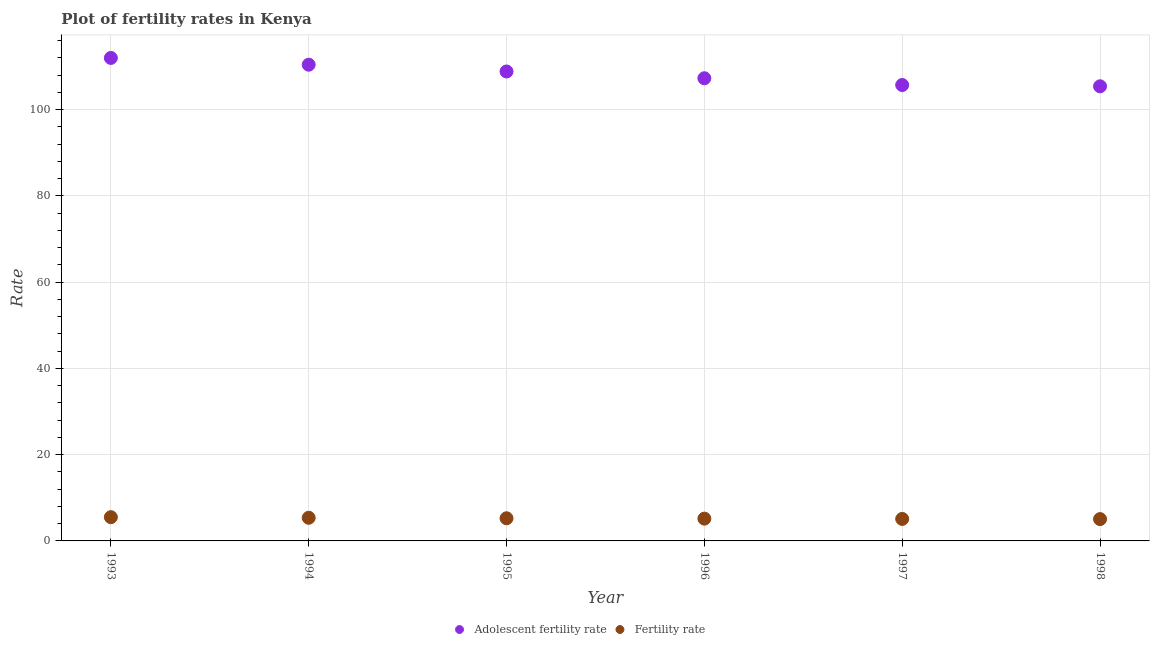Is the number of dotlines equal to the number of legend labels?
Give a very brief answer. Yes. What is the adolescent fertility rate in 1998?
Your response must be concise. 105.4. Across all years, what is the maximum fertility rate?
Offer a terse response. 5.51. Across all years, what is the minimum adolescent fertility rate?
Offer a very short reply. 105.4. In which year was the fertility rate minimum?
Provide a succinct answer. 1998. What is the total fertility rate in the graph?
Make the answer very short. 31.45. What is the difference between the fertility rate in 1997 and that in 1998?
Provide a short and direct response. 0.04. What is the difference between the adolescent fertility rate in 1997 and the fertility rate in 1998?
Your answer should be very brief. 100.64. What is the average fertility rate per year?
Give a very brief answer. 5.24. In the year 1997, what is the difference between the fertility rate and adolescent fertility rate?
Keep it short and to the point. -100.6. What is the ratio of the fertility rate in 1996 to that in 1998?
Offer a very short reply. 1.02. Is the adolescent fertility rate in 1997 less than that in 1998?
Provide a short and direct response. No. What is the difference between the highest and the second highest adolescent fertility rate?
Your answer should be compact. 1.57. What is the difference between the highest and the lowest adolescent fertility rate?
Provide a succinct answer. 6.58. In how many years, is the fertility rate greater than the average fertility rate taken over all years?
Provide a short and direct response. 3. Is the adolescent fertility rate strictly less than the fertility rate over the years?
Your response must be concise. No. What is the difference between two consecutive major ticks on the Y-axis?
Give a very brief answer. 20. Are the values on the major ticks of Y-axis written in scientific E-notation?
Offer a terse response. No. Does the graph contain any zero values?
Offer a very short reply. No. Where does the legend appear in the graph?
Offer a terse response. Bottom center. How many legend labels are there?
Keep it short and to the point. 2. How are the legend labels stacked?
Your answer should be very brief. Horizontal. What is the title of the graph?
Provide a short and direct response. Plot of fertility rates in Kenya. Does "Gasoline" appear as one of the legend labels in the graph?
Your answer should be very brief. No. What is the label or title of the X-axis?
Provide a short and direct response. Year. What is the label or title of the Y-axis?
Provide a succinct answer. Rate. What is the Rate in Adolescent fertility rate in 1993?
Your answer should be very brief. 111.98. What is the Rate in Fertility rate in 1993?
Give a very brief answer. 5.51. What is the Rate of Adolescent fertility rate in 1994?
Give a very brief answer. 110.41. What is the Rate in Fertility rate in 1994?
Make the answer very short. 5.37. What is the Rate in Adolescent fertility rate in 1995?
Provide a succinct answer. 108.84. What is the Rate in Fertility rate in 1995?
Offer a very short reply. 5.25. What is the Rate of Adolescent fertility rate in 1996?
Provide a short and direct response. 107.27. What is the Rate of Fertility rate in 1996?
Your answer should be compact. 5.17. What is the Rate of Adolescent fertility rate in 1997?
Offer a terse response. 105.7. What is the Rate in Fertility rate in 1997?
Your answer should be compact. 5.1. What is the Rate of Adolescent fertility rate in 1998?
Your answer should be compact. 105.4. What is the Rate in Fertility rate in 1998?
Provide a succinct answer. 5.06. Across all years, what is the maximum Rate in Adolescent fertility rate?
Keep it short and to the point. 111.98. Across all years, what is the maximum Rate of Fertility rate?
Keep it short and to the point. 5.51. Across all years, what is the minimum Rate in Adolescent fertility rate?
Offer a very short reply. 105.4. Across all years, what is the minimum Rate of Fertility rate?
Keep it short and to the point. 5.06. What is the total Rate of Adolescent fertility rate in the graph?
Provide a succinct answer. 649.59. What is the total Rate of Fertility rate in the graph?
Offer a terse response. 31.45. What is the difference between the Rate of Adolescent fertility rate in 1993 and that in 1994?
Provide a succinct answer. 1.57. What is the difference between the Rate of Fertility rate in 1993 and that in 1994?
Your answer should be compact. 0.14. What is the difference between the Rate of Adolescent fertility rate in 1993 and that in 1995?
Offer a terse response. 3.14. What is the difference between the Rate in Fertility rate in 1993 and that in 1995?
Give a very brief answer. 0.26. What is the difference between the Rate in Adolescent fertility rate in 1993 and that in 1996?
Your answer should be very brief. 4.71. What is the difference between the Rate in Fertility rate in 1993 and that in 1996?
Provide a short and direct response. 0.34. What is the difference between the Rate of Adolescent fertility rate in 1993 and that in 1997?
Your response must be concise. 6.28. What is the difference between the Rate of Fertility rate in 1993 and that in 1997?
Keep it short and to the point. 0.4. What is the difference between the Rate in Adolescent fertility rate in 1993 and that in 1998?
Ensure brevity in your answer.  6.58. What is the difference between the Rate in Fertility rate in 1993 and that in 1998?
Offer a very short reply. 0.45. What is the difference between the Rate in Adolescent fertility rate in 1994 and that in 1995?
Ensure brevity in your answer.  1.57. What is the difference between the Rate in Fertility rate in 1994 and that in 1995?
Ensure brevity in your answer.  0.12. What is the difference between the Rate in Adolescent fertility rate in 1994 and that in 1996?
Offer a very short reply. 3.14. What is the difference between the Rate of Fertility rate in 1994 and that in 1996?
Offer a very short reply. 0.2. What is the difference between the Rate of Adolescent fertility rate in 1994 and that in 1997?
Keep it short and to the point. 4.71. What is the difference between the Rate in Fertility rate in 1994 and that in 1997?
Provide a succinct answer. 0.26. What is the difference between the Rate in Adolescent fertility rate in 1994 and that in 1998?
Make the answer very short. 5.01. What is the difference between the Rate of Fertility rate in 1994 and that in 1998?
Offer a very short reply. 0.31. What is the difference between the Rate in Adolescent fertility rate in 1995 and that in 1996?
Your answer should be very brief. 1.57. What is the difference between the Rate of Fertility rate in 1995 and that in 1996?
Your answer should be compact. 0.09. What is the difference between the Rate in Adolescent fertility rate in 1995 and that in 1997?
Your response must be concise. 3.14. What is the difference between the Rate of Fertility rate in 1995 and that in 1997?
Provide a succinct answer. 0.15. What is the difference between the Rate in Adolescent fertility rate in 1995 and that in 1998?
Make the answer very short. 3.44. What is the difference between the Rate in Fertility rate in 1995 and that in 1998?
Keep it short and to the point. 0.19. What is the difference between the Rate of Adolescent fertility rate in 1996 and that in 1997?
Make the answer very short. 1.57. What is the difference between the Rate of Fertility rate in 1996 and that in 1997?
Make the answer very short. 0.06. What is the difference between the Rate of Adolescent fertility rate in 1996 and that in 1998?
Offer a terse response. 1.87. What is the difference between the Rate in Fertility rate in 1996 and that in 1998?
Your answer should be compact. 0.11. What is the difference between the Rate of Fertility rate in 1997 and that in 1998?
Your answer should be very brief. 0.04. What is the difference between the Rate of Adolescent fertility rate in 1993 and the Rate of Fertility rate in 1994?
Offer a very short reply. 106.61. What is the difference between the Rate in Adolescent fertility rate in 1993 and the Rate in Fertility rate in 1995?
Your answer should be very brief. 106.73. What is the difference between the Rate of Adolescent fertility rate in 1993 and the Rate of Fertility rate in 1996?
Provide a short and direct response. 106.81. What is the difference between the Rate of Adolescent fertility rate in 1993 and the Rate of Fertility rate in 1997?
Provide a succinct answer. 106.87. What is the difference between the Rate of Adolescent fertility rate in 1993 and the Rate of Fertility rate in 1998?
Your answer should be very brief. 106.92. What is the difference between the Rate of Adolescent fertility rate in 1994 and the Rate of Fertility rate in 1995?
Give a very brief answer. 105.16. What is the difference between the Rate in Adolescent fertility rate in 1994 and the Rate in Fertility rate in 1996?
Give a very brief answer. 105.24. What is the difference between the Rate in Adolescent fertility rate in 1994 and the Rate in Fertility rate in 1997?
Give a very brief answer. 105.31. What is the difference between the Rate in Adolescent fertility rate in 1994 and the Rate in Fertility rate in 1998?
Ensure brevity in your answer.  105.35. What is the difference between the Rate in Adolescent fertility rate in 1995 and the Rate in Fertility rate in 1996?
Keep it short and to the point. 103.67. What is the difference between the Rate of Adolescent fertility rate in 1995 and the Rate of Fertility rate in 1997?
Give a very brief answer. 103.74. What is the difference between the Rate of Adolescent fertility rate in 1995 and the Rate of Fertility rate in 1998?
Ensure brevity in your answer.  103.78. What is the difference between the Rate in Adolescent fertility rate in 1996 and the Rate in Fertility rate in 1997?
Ensure brevity in your answer.  102.17. What is the difference between the Rate of Adolescent fertility rate in 1996 and the Rate of Fertility rate in 1998?
Keep it short and to the point. 102.21. What is the difference between the Rate of Adolescent fertility rate in 1997 and the Rate of Fertility rate in 1998?
Your answer should be very brief. 100.64. What is the average Rate in Adolescent fertility rate per year?
Give a very brief answer. 108.27. What is the average Rate of Fertility rate per year?
Make the answer very short. 5.24. In the year 1993, what is the difference between the Rate in Adolescent fertility rate and Rate in Fertility rate?
Give a very brief answer. 106.47. In the year 1994, what is the difference between the Rate of Adolescent fertility rate and Rate of Fertility rate?
Ensure brevity in your answer.  105.04. In the year 1995, what is the difference between the Rate in Adolescent fertility rate and Rate in Fertility rate?
Provide a succinct answer. 103.59. In the year 1996, what is the difference between the Rate in Adolescent fertility rate and Rate in Fertility rate?
Offer a very short reply. 102.1. In the year 1997, what is the difference between the Rate in Adolescent fertility rate and Rate in Fertility rate?
Your response must be concise. 100.6. In the year 1998, what is the difference between the Rate in Adolescent fertility rate and Rate in Fertility rate?
Provide a short and direct response. 100.34. What is the ratio of the Rate in Adolescent fertility rate in 1993 to that in 1994?
Offer a terse response. 1.01. What is the ratio of the Rate of Fertility rate in 1993 to that in 1994?
Your answer should be very brief. 1.03. What is the ratio of the Rate of Adolescent fertility rate in 1993 to that in 1995?
Make the answer very short. 1.03. What is the ratio of the Rate in Fertility rate in 1993 to that in 1995?
Your answer should be very brief. 1.05. What is the ratio of the Rate of Adolescent fertility rate in 1993 to that in 1996?
Offer a terse response. 1.04. What is the ratio of the Rate of Fertility rate in 1993 to that in 1996?
Ensure brevity in your answer.  1.07. What is the ratio of the Rate in Adolescent fertility rate in 1993 to that in 1997?
Provide a short and direct response. 1.06. What is the ratio of the Rate in Fertility rate in 1993 to that in 1997?
Ensure brevity in your answer.  1.08. What is the ratio of the Rate of Adolescent fertility rate in 1993 to that in 1998?
Your answer should be very brief. 1.06. What is the ratio of the Rate in Fertility rate in 1993 to that in 1998?
Your answer should be very brief. 1.09. What is the ratio of the Rate of Adolescent fertility rate in 1994 to that in 1995?
Offer a terse response. 1.01. What is the ratio of the Rate in Fertility rate in 1994 to that in 1995?
Offer a terse response. 1.02. What is the ratio of the Rate of Adolescent fertility rate in 1994 to that in 1996?
Keep it short and to the point. 1.03. What is the ratio of the Rate of Fertility rate in 1994 to that in 1996?
Your answer should be very brief. 1.04. What is the ratio of the Rate in Adolescent fertility rate in 1994 to that in 1997?
Give a very brief answer. 1.04. What is the ratio of the Rate in Fertility rate in 1994 to that in 1997?
Offer a terse response. 1.05. What is the ratio of the Rate in Adolescent fertility rate in 1994 to that in 1998?
Provide a short and direct response. 1.05. What is the ratio of the Rate in Fertility rate in 1994 to that in 1998?
Your response must be concise. 1.06. What is the ratio of the Rate of Adolescent fertility rate in 1995 to that in 1996?
Offer a very short reply. 1.01. What is the ratio of the Rate of Fertility rate in 1995 to that in 1996?
Offer a terse response. 1.02. What is the ratio of the Rate of Adolescent fertility rate in 1995 to that in 1997?
Offer a very short reply. 1.03. What is the ratio of the Rate in Fertility rate in 1995 to that in 1997?
Provide a short and direct response. 1.03. What is the ratio of the Rate of Adolescent fertility rate in 1995 to that in 1998?
Offer a terse response. 1.03. What is the ratio of the Rate in Fertility rate in 1995 to that in 1998?
Your response must be concise. 1.04. What is the ratio of the Rate in Adolescent fertility rate in 1996 to that in 1997?
Offer a very short reply. 1.01. What is the ratio of the Rate of Fertility rate in 1996 to that in 1997?
Keep it short and to the point. 1.01. What is the ratio of the Rate of Adolescent fertility rate in 1996 to that in 1998?
Offer a terse response. 1.02. What is the ratio of the Rate of Fertility rate in 1997 to that in 1998?
Your answer should be compact. 1.01. What is the difference between the highest and the second highest Rate in Adolescent fertility rate?
Provide a short and direct response. 1.57. What is the difference between the highest and the second highest Rate in Fertility rate?
Provide a succinct answer. 0.14. What is the difference between the highest and the lowest Rate in Adolescent fertility rate?
Give a very brief answer. 6.58. What is the difference between the highest and the lowest Rate of Fertility rate?
Ensure brevity in your answer.  0.45. 